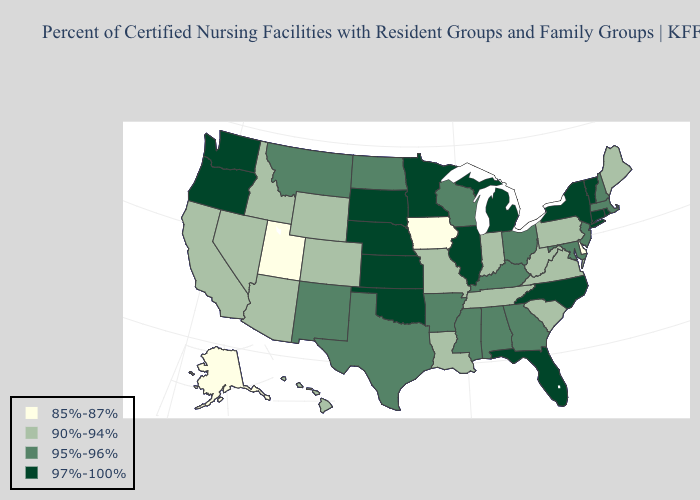Does Wisconsin have the same value as Arkansas?
Be succinct. Yes. Does Minnesota have the same value as Pennsylvania?
Quick response, please. No. Does Oregon have the highest value in the USA?
Quick response, please. Yes. What is the value of Massachusetts?
Write a very short answer. 95%-96%. Name the states that have a value in the range 85%-87%?
Keep it brief. Alaska, Delaware, Iowa, Utah. Which states hav the highest value in the Northeast?
Short answer required. Connecticut, New York, Rhode Island, Vermont. What is the value of Idaho?
Be succinct. 90%-94%. Does Wisconsin have a lower value than Connecticut?
Keep it brief. Yes. What is the value of West Virginia?
Quick response, please. 90%-94%. What is the value of Wisconsin?
Short answer required. 95%-96%. What is the value of Wisconsin?
Give a very brief answer. 95%-96%. What is the highest value in states that border New York?
Concise answer only. 97%-100%. Among the states that border Utah , does Wyoming have the lowest value?
Short answer required. Yes. What is the value of Wyoming?
Answer briefly. 90%-94%. 